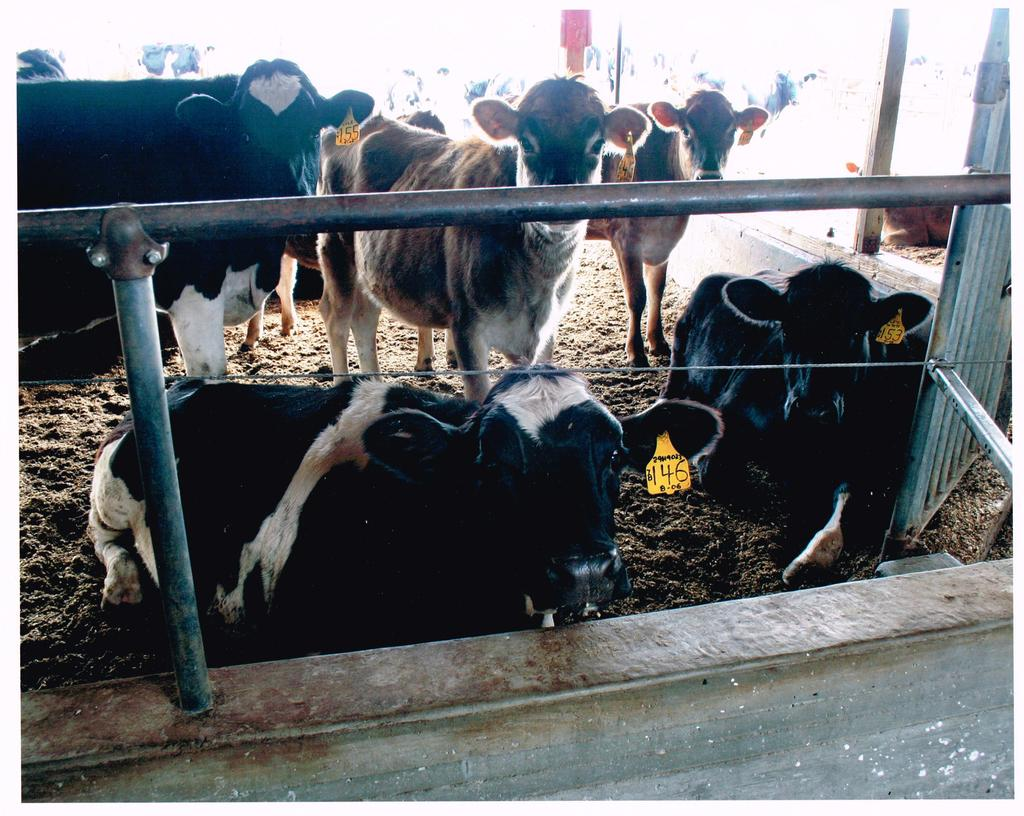What animals are in the center of the image? There are cows in the center of the image. What type of fencing is present in the image? There is a metal fencing in the image. What type of terrain is visible at the bottom of the image? There is sand visible at the bottom of the image. What time of day is it in the image, specifically in the afternoon? The time of day is not mentioned or indicated in the image, so it cannot be determined if it is in the afternoon. 